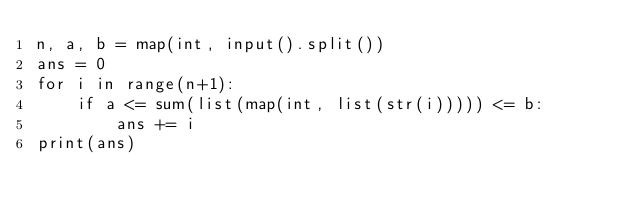Convert code to text. <code><loc_0><loc_0><loc_500><loc_500><_Python_>n, a, b = map(int, input().split())
ans = 0
for i in range(n+1):
    if a <= sum(list(map(int, list(str(i))))) <= b:
        ans += i
print(ans)</code> 